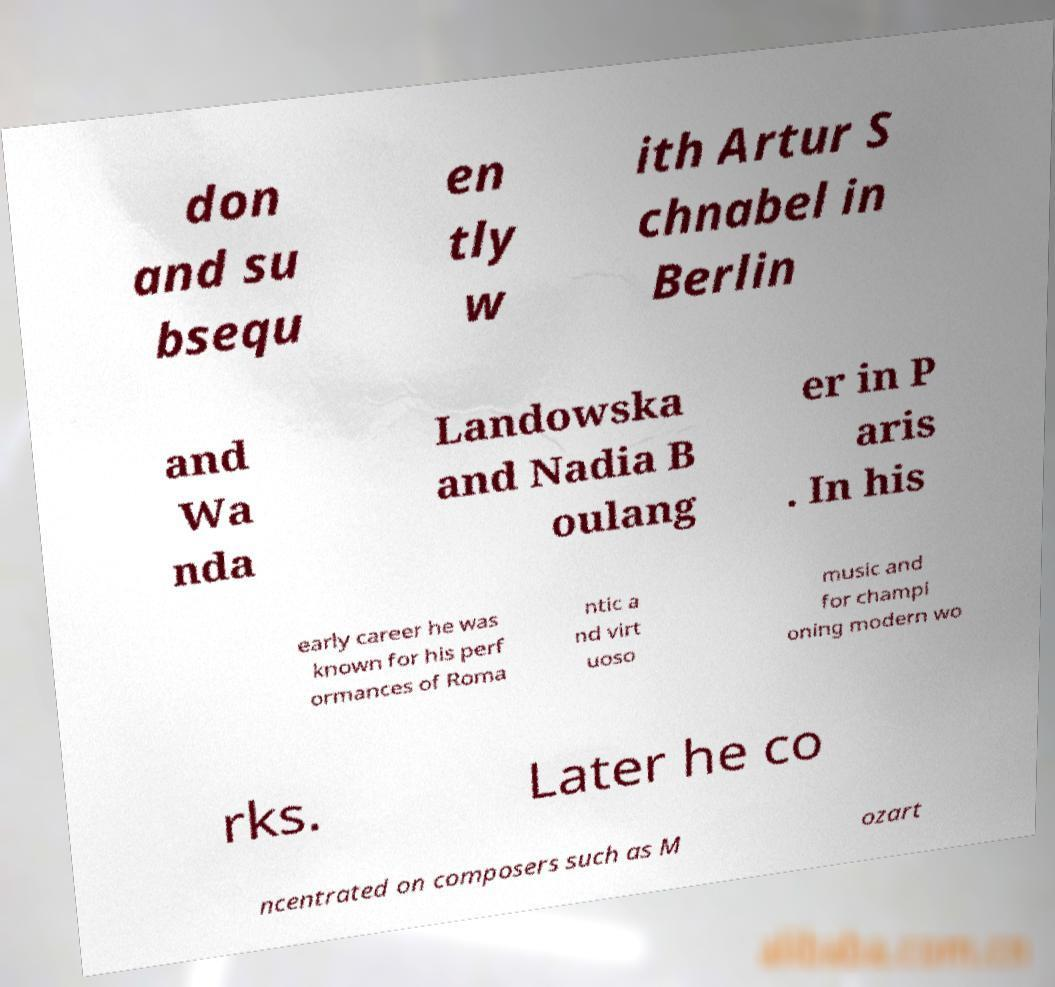Could you assist in decoding the text presented in this image and type it out clearly? don and su bsequ en tly w ith Artur S chnabel in Berlin and Wa nda Landowska and Nadia B oulang er in P aris . In his early career he was known for his perf ormances of Roma ntic a nd virt uoso music and for champi oning modern wo rks. Later he co ncentrated on composers such as M ozart 